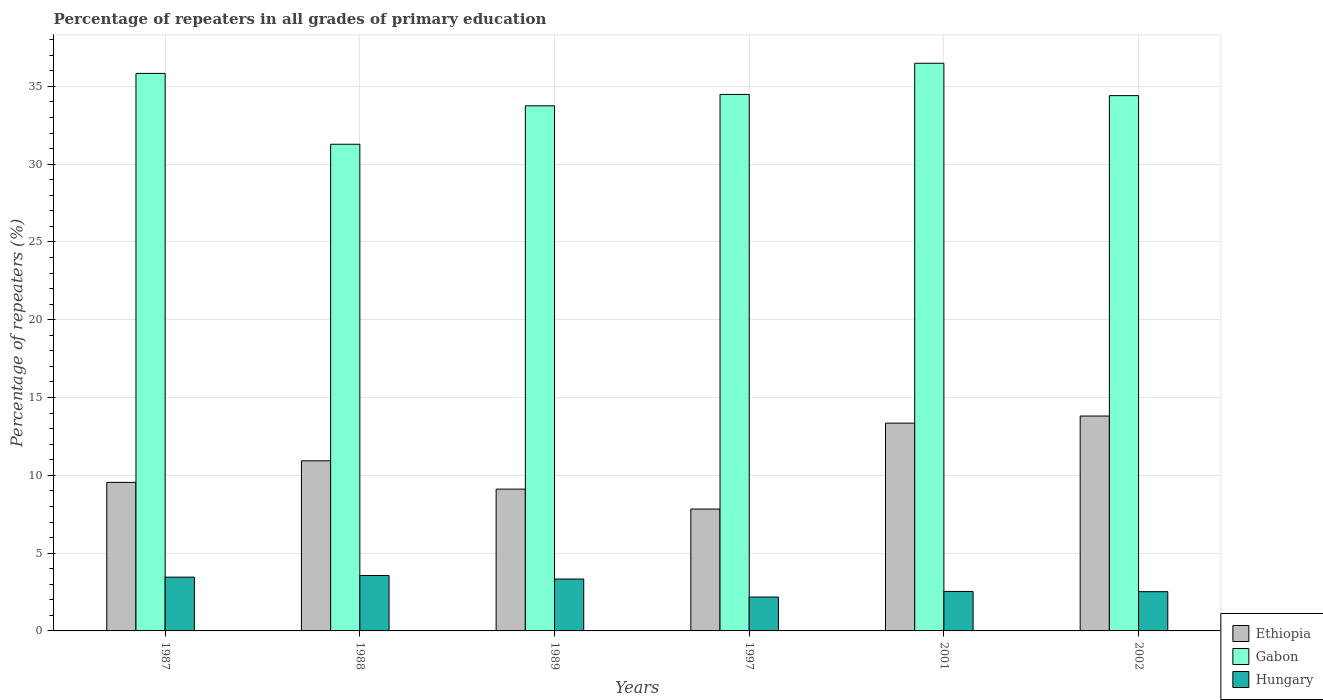How many different coloured bars are there?
Your response must be concise. 3. Are the number of bars per tick equal to the number of legend labels?
Keep it short and to the point. Yes. How many bars are there on the 4th tick from the left?
Keep it short and to the point. 3. How many bars are there on the 4th tick from the right?
Offer a terse response. 3. What is the percentage of repeaters in Hungary in 2001?
Your answer should be compact. 2.54. Across all years, what is the maximum percentage of repeaters in Hungary?
Your answer should be compact. 3.56. Across all years, what is the minimum percentage of repeaters in Gabon?
Your answer should be compact. 31.28. In which year was the percentage of repeaters in Hungary maximum?
Offer a terse response. 1988. In which year was the percentage of repeaters in Ethiopia minimum?
Your answer should be compact. 1997. What is the total percentage of repeaters in Gabon in the graph?
Your response must be concise. 206.24. What is the difference between the percentage of repeaters in Hungary in 1988 and that in 2001?
Offer a very short reply. 1.03. What is the difference between the percentage of repeaters in Ethiopia in 1997 and the percentage of repeaters in Hungary in 2002?
Keep it short and to the point. 5.31. What is the average percentage of repeaters in Hungary per year?
Your response must be concise. 2.93. In the year 1989, what is the difference between the percentage of repeaters in Gabon and percentage of repeaters in Ethiopia?
Ensure brevity in your answer.  24.64. What is the ratio of the percentage of repeaters in Hungary in 1997 to that in 2001?
Your answer should be compact. 0.86. Is the percentage of repeaters in Gabon in 1987 less than that in 1989?
Make the answer very short. No. Is the difference between the percentage of repeaters in Gabon in 1987 and 2002 greater than the difference between the percentage of repeaters in Ethiopia in 1987 and 2002?
Provide a short and direct response. Yes. What is the difference between the highest and the second highest percentage of repeaters in Gabon?
Offer a terse response. 0.65. What is the difference between the highest and the lowest percentage of repeaters in Hungary?
Ensure brevity in your answer.  1.39. What does the 1st bar from the left in 2002 represents?
Give a very brief answer. Ethiopia. What does the 2nd bar from the right in 1997 represents?
Provide a short and direct response. Gabon. Is it the case that in every year, the sum of the percentage of repeaters in Hungary and percentage of repeaters in Gabon is greater than the percentage of repeaters in Ethiopia?
Give a very brief answer. Yes. How many bars are there?
Give a very brief answer. 18. Are all the bars in the graph horizontal?
Ensure brevity in your answer.  No. How many years are there in the graph?
Offer a very short reply. 6. What is the difference between two consecutive major ticks on the Y-axis?
Keep it short and to the point. 5. Are the values on the major ticks of Y-axis written in scientific E-notation?
Make the answer very short. No. Does the graph contain any zero values?
Make the answer very short. No. Does the graph contain grids?
Give a very brief answer. Yes. Where does the legend appear in the graph?
Keep it short and to the point. Bottom right. How many legend labels are there?
Make the answer very short. 3. How are the legend labels stacked?
Your answer should be very brief. Vertical. What is the title of the graph?
Provide a succinct answer. Percentage of repeaters in all grades of primary education. Does "Low income" appear as one of the legend labels in the graph?
Give a very brief answer. No. What is the label or title of the X-axis?
Your answer should be compact. Years. What is the label or title of the Y-axis?
Keep it short and to the point. Percentage of repeaters (%). What is the Percentage of repeaters (%) of Ethiopia in 1987?
Offer a terse response. 9.55. What is the Percentage of repeaters (%) of Gabon in 1987?
Offer a terse response. 35.83. What is the Percentage of repeaters (%) of Hungary in 1987?
Your answer should be compact. 3.46. What is the Percentage of repeaters (%) in Ethiopia in 1988?
Your response must be concise. 10.93. What is the Percentage of repeaters (%) in Gabon in 1988?
Give a very brief answer. 31.28. What is the Percentage of repeaters (%) in Hungary in 1988?
Your answer should be very brief. 3.56. What is the Percentage of repeaters (%) in Ethiopia in 1989?
Your answer should be compact. 9.11. What is the Percentage of repeaters (%) of Gabon in 1989?
Make the answer very short. 33.75. What is the Percentage of repeaters (%) in Hungary in 1989?
Offer a terse response. 3.33. What is the Percentage of repeaters (%) in Ethiopia in 1997?
Provide a succinct answer. 7.83. What is the Percentage of repeaters (%) of Gabon in 1997?
Provide a short and direct response. 34.48. What is the Percentage of repeaters (%) of Hungary in 1997?
Your response must be concise. 2.18. What is the Percentage of repeaters (%) in Ethiopia in 2001?
Your response must be concise. 13.36. What is the Percentage of repeaters (%) of Gabon in 2001?
Offer a very short reply. 36.49. What is the Percentage of repeaters (%) of Hungary in 2001?
Make the answer very short. 2.54. What is the Percentage of repeaters (%) of Ethiopia in 2002?
Make the answer very short. 13.81. What is the Percentage of repeaters (%) of Gabon in 2002?
Your response must be concise. 34.41. What is the Percentage of repeaters (%) in Hungary in 2002?
Your response must be concise. 2.52. Across all years, what is the maximum Percentage of repeaters (%) of Ethiopia?
Provide a short and direct response. 13.81. Across all years, what is the maximum Percentage of repeaters (%) in Gabon?
Ensure brevity in your answer.  36.49. Across all years, what is the maximum Percentage of repeaters (%) in Hungary?
Keep it short and to the point. 3.56. Across all years, what is the minimum Percentage of repeaters (%) in Ethiopia?
Offer a very short reply. 7.83. Across all years, what is the minimum Percentage of repeaters (%) of Gabon?
Your answer should be very brief. 31.28. Across all years, what is the minimum Percentage of repeaters (%) in Hungary?
Provide a short and direct response. 2.18. What is the total Percentage of repeaters (%) of Ethiopia in the graph?
Your answer should be very brief. 64.6. What is the total Percentage of repeaters (%) of Gabon in the graph?
Give a very brief answer. 206.24. What is the total Percentage of repeaters (%) of Hungary in the graph?
Make the answer very short. 17.59. What is the difference between the Percentage of repeaters (%) in Ethiopia in 1987 and that in 1988?
Provide a short and direct response. -1.39. What is the difference between the Percentage of repeaters (%) in Gabon in 1987 and that in 1988?
Offer a very short reply. 4.55. What is the difference between the Percentage of repeaters (%) in Hungary in 1987 and that in 1988?
Provide a succinct answer. -0.11. What is the difference between the Percentage of repeaters (%) of Ethiopia in 1987 and that in 1989?
Your answer should be very brief. 0.43. What is the difference between the Percentage of repeaters (%) in Gabon in 1987 and that in 1989?
Your answer should be compact. 2.08. What is the difference between the Percentage of repeaters (%) of Hungary in 1987 and that in 1989?
Offer a very short reply. 0.12. What is the difference between the Percentage of repeaters (%) in Ethiopia in 1987 and that in 1997?
Offer a very short reply. 1.71. What is the difference between the Percentage of repeaters (%) in Gabon in 1987 and that in 1997?
Ensure brevity in your answer.  1.35. What is the difference between the Percentage of repeaters (%) of Hungary in 1987 and that in 1997?
Offer a terse response. 1.28. What is the difference between the Percentage of repeaters (%) in Ethiopia in 1987 and that in 2001?
Give a very brief answer. -3.81. What is the difference between the Percentage of repeaters (%) in Gabon in 1987 and that in 2001?
Give a very brief answer. -0.65. What is the difference between the Percentage of repeaters (%) in Hungary in 1987 and that in 2001?
Give a very brief answer. 0.92. What is the difference between the Percentage of repeaters (%) of Ethiopia in 1987 and that in 2002?
Provide a short and direct response. -4.27. What is the difference between the Percentage of repeaters (%) in Gabon in 1987 and that in 2002?
Your answer should be very brief. 1.43. What is the difference between the Percentage of repeaters (%) in Hungary in 1987 and that in 2002?
Your answer should be very brief. 0.93. What is the difference between the Percentage of repeaters (%) of Ethiopia in 1988 and that in 1989?
Provide a succinct answer. 1.82. What is the difference between the Percentage of repeaters (%) of Gabon in 1988 and that in 1989?
Provide a succinct answer. -2.47. What is the difference between the Percentage of repeaters (%) of Hungary in 1988 and that in 1989?
Make the answer very short. 0.23. What is the difference between the Percentage of repeaters (%) in Ethiopia in 1988 and that in 1997?
Provide a succinct answer. 3.1. What is the difference between the Percentage of repeaters (%) of Gabon in 1988 and that in 1997?
Provide a short and direct response. -3.2. What is the difference between the Percentage of repeaters (%) in Hungary in 1988 and that in 1997?
Provide a succinct answer. 1.39. What is the difference between the Percentage of repeaters (%) in Ethiopia in 1988 and that in 2001?
Make the answer very short. -2.42. What is the difference between the Percentage of repeaters (%) in Gabon in 1988 and that in 2001?
Make the answer very short. -5.21. What is the difference between the Percentage of repeaters (%) in Hungary in 1988 and that in 2001?
Your answer should be very brief. 1.03. What is the difference between the Percentage of repeaters (%) in Ethiopia in 1988 and that in 2002?
Offer a terse response. -2.88. What is the difference between the Percentage of repeaters (%) of Gabon in 1988 and that in 2002?
Your answer should be very brief. -3.12. What is the difference between the Percentage of repeaters (%) in Hungary in 1988 and that in 2002?
Provide a short and direct response. 1.04. What is the difference between the Percentage of repeaters (%) in Ethiopia in 1989 and that in 1997?
Make the answer very short. 1.28. What is the difference between the Percentage of repeaters (%) in Gabon in 1989 and that in 1997?
Make the answer very short. -0.73. What is the difference between the Percentage of repeaters (%) of Hungary in 1989 and that in 1997?
Ensure brevity in your answer.  1.16. What is the difference between the Percentage of repeaters (%) in Ethiopia in 1989 and that in 2001?
Offer a terse response. -4.24. What is the difference between the Percentage of repeaters (%) of Gabon in 1989 and that in 2001?
Offer a very short reply. -2.73. What is the difference between the Percentage of repeaters (%) of Hungary in 1989 and that in 2001?
Ensure brevity in your answer.  0.8. What is the difference between the Percentage of repeaters (%) in Ethiopia in 1989 and that in 2002?
Provide a short and direct response. -4.7. What is the difference between the Percentage of repeaters (%) of Gabon in 1989 and that in 2002?
Provide a succinct answer. -0.65. What is the difference between the Percentage of repeaters (%) of Hungary in 1989 and that in 2002?
Offer a terse response. 0.81. What is the difference between the Percentage of repeaters (%) in Ethiopia in 1997 and that in 2001?
Ensure brevity in your answer.  -5.52. What is the difference between the Percentage of repeaters (%) of Gabon in 1997 and that in 2001?
Your answer should be very brief. -2. What is the difference between the Percentage of repeaters (%) of Hungary in 1997 and that in 2001?
Give a very brief answer. -0.36. What is the difference between the Percentage of repeaters (%) in Ethiopia in 1997 and that in 2002?
Make the answer very short. -5.98. What is the difference between the Percentage of repeaters (%) in Gabon in 1997 and that in 2002?
Your answer should be compact. 0.08. What is the difference between the Percentage of repeaters (%) in Hungary in 1997 and that in 2002?
Provide a succinct answer. -0.34. What is the difference between the Percentage of repeaters (%) of Ethiopia in 2001 and that in 2002?
Make the answer very short. -0.46. What is the difference between the Percentage of repeaters (%) of Gabon in 2001 and that in 2002?
Ensure brevity in your answer.  2.08. What is the difference between the Percentage of repeaters (%) of Hungary in 2001 and that in 2002?
Make the answer very short. 0.01. What is the difference between the Percentage of repeaters (%) of Ethiopia in 1987 and the Percentage of repeaters (%) of Gabon in 1988?
Your answer should be very brief. -21.73. What is the difference between the Percentage of repeaters (%) in Ethiopia in 1987 and the Percentage of repeaters (%) in Hungary in 1988?
Your response must be concise. 5.98. What is the difference between the Percentage of repeaters (%) of Gabon in 1987 and the Percentage of repeaters (%) of Hungary in 1988?
Your response must be concise. 32.27. What is the difference between the Percentage of repeaters (%) in Ethiopia in 1987 and the Percentage of repeaters (%) in Gabon in 1989?
Make the answer very short. -24.21. What is the difference between the Percentage of repeaters (%) in Ethiopia in 1987 and the Percentage of repeaters (%) in Hungary in 1989?
Provide a short and direct response. 6.21. What is the difference between the Percentage of repeaters (%) of Gabon in 1987 and the Percentage of repeaters (%) of Hungary in 1989?
Keep it short and to the point. 32.5. What is the difference between the Percentage of repeaters (%) in Ethiopia in 1987 and the Percentage of repeaters (%) in Gabon in 1997?
Your response must be concise. -24.94. What is the difference between the Percentage of repeaters (%) in Ethiopia in 1987 and the Percentage of repeaters (%) in Hungary in 1997?
Offer a terse response. 7.37. What is the difference between the Percentage of repeaters (%) in Gabon in 1987 and the Percentage of repeaters (%) in Hungary in 1997?
Provide a short and direct response. 33.66. What is the difference between the Percentage of repeaters (%) of Ethiopia in 1987 and the Percentage of repeaters (%) of Gabon in 2001?
Keep it short and to the point. -26.94. What is the difference between the Percentage of repeaters (%) of Ethiopia in 1987 and the Percentage of repeaters (%) of Hungary in 2001?
Offer a terse response. 7.01. What is the difference between the Percentage of repeaters (%) in Gabon in 1987 and the Percentage of repeaters (%) in Hungary in 2001?
Provide a succinct answer. 33.3. What is the difference between the Percentage of repeaters (%) of Ethiopia in 1987 and the Percentage of repeaters (%) of Gabon in 2002?
Ensure brevity in your answer.  -24.86. What is the difference between the Percentage of repeaters (%) in Ethiopia in 1987 and the Percentage of repeaters (%) in Hungary in 2002?
Offer a very short reply. 7.02. What is the difference between the Percentage of repeaters (%) in Gabon in 1987 and the Percentage of repeaters (%) in Hungary in 2002?
Ensure brevity in your answer.  33.31. What is the difference between the Percentage of repeaters (%) of Ethiopia in 1988 and the Percentage of repeaters (%) of Gabon in 1989?
Ensure brevity in your answer.  -22.82. What is the difference between the Percentage of repeaters (%) in Ethiopia in 1988 and the Percentage of repeaters (%) in Hungary in 1989?
Ensure brevity in your answer.  7.6. What is the difference between the Percentage of repeaters (%) of Gabon in 1988 and the Percentage of repeaters (%) of Hungary in 1989?
Give a very brief answer. 27.95. What is the difference between the Percentage of repeaters (%) of Ethiopia in 1988 and the Percentage of repeaters (%) of Gabon in 1997?
Your answer should be compact. -23.55. What is the difference between the Percentage of repeaters (%) of Ethiopia in 1988 and the Percentage of repeaters (%) of Hungary in 1997?
Provide a succinct answer. 8.76. What is the difference between the Percentage of repeaters (%) of Gabon in 1988 and the Percentage of repeaters (%) of Hungary in 1997?
Keep it short and to the point. 29.1. What is the difference between the Percentage of repeaters (%) in Ethiopia in 1988 and the Percentage of repeaters (%) in Gabon in 2001?
Your response must be concise. -25.55. What is the difference between the Percentage of repeaters (%) of Ethiopia in 1988 and the Percentage of repeaters (%) of Hungary in 2001?
Ensure brevity in your answer.  8.4. What is the difference between the Percentage of repeaters (%) in Gabon in 1988 and the Percentage of repeaters (%) in Hungary in 2001?
Make the answer very short. 28.74. What is the difference between the Percentage of repeaters (%) of Ethiopia in 1988 and the Percentage of repeaters (%) of Gabon in 2002?
Your answer should be very brief. -23.47. What is the difference between the Percentage of repeaters (%) of Ethiopia in 1988 and the Percentage of repeaters (%) of Hungary in 2002?
Give a very brief answer. 8.41. What is the difference between the Percentage of repeaters (%) of Gabon in 1988 and the Percentage of repeaters (%) of Hungary in 2002?
Provide a succinct answer. 28.76. What is the difference between the Percentage of repeaters (%) of Ethiopia in 1989 and the Percentage of repeaters (%) of Gabon in 1997?
Make the answer very short. -25.37. What is the difference between the Percentage of repeaters (%) in Ethiopia in 1989 and the Percentage of repeaters (%) in Hungary in 1997?
Ensure brevity in your answer.  6.94. What is the difference between the Percentage of repeaters (%) in Gabon in 1989 and the Percentage of repeaters (%) in Hungary in 1997?
Keep it short and to the point. 31.57. What is the difference between the Percentage of repeaters (%) in Ethiopia in 1989 and the Percentage of repeaters (%) in Gabon in 2001?
Make the answer very short. -27.37. What is the difference between the Percentage of repeaters (%) in Ethiopia in 1989 and the Percentage of repeaters (%) in Hungary in 2001?
Offer a terse response. 6.58. What is the difference between the Percentage of repeaters (%) of Gabon in 1989 and the Percentage of repeaters (%) of Hungary in 2001?
Ensure brevity in your answer.  31.22. What is the difference between the Percentage of repeaters (%) of Ethiopia in 1989 and the Percentage of repeaters (%) of Gabon in 2002?
Provide a short and direct response. -25.29. What is the difference between the Percentage of repeaters (%) of Ethiopia in 1989 and the Percentage of repeaters (%) of Hungary in 2002?
Your response must be concise. 6.59. What is the difference between the Percentage of repeaters (%) in Gabon in 1989 and the Percentage of repeaters (%) in Hungary in 2002?
Make the answer very short. 31.23. What is the difference between the Percentage of repeaters (%) of Ethiopia in 1997 and the Percentage of repeaters (%) of Gabon in 2001?
Provide a succinct answer. -28.65. What is the difference between the Percentage of repeaters (%) in Ethiopia in 1997 and the Percentage of repeaters (%) in Hungary in 2001?
Your answer should be very brief. 5.3. What is the difference between the Percentage of repeaters (%) in Gabon in 1997 and the Percentage of repeaters (%) in Hungary in 2001?
Your answer should be compact. 31.95. What is the difference between the Percentage of repeaters (%) of Ethiopia in 1997 and the Percentage of repeaters (%) of Gabon in 2002?
Provide a succinct answer. -26.57. What is the difference between the Percentage of repeaters (%) in Ethiopia in 1997 and the Percentage of repeaters (%) in Hungary in 2002?
Provide a succinct answer. 5.31. What is the difference between the Percentage of repeaters (%) of Gabon in 1997 and the Percentage of repeaters (%) of Hungary in 2002?
Provide a succinct answer. 31.96. What is the difference between the Percentage of repeaters (%) in Ethiopia in 2001 and the Percentage of repeaters (%) in Gabon in 2002?
Ensure brevity in your answer.  -21.05. What is the difference between the Percentage of repeaters (%) in Ethiopia in 2001 and the Percentage of repeaters (%) in Hungary in 2002?
Ensure brevity in your answer.  10.83. What is the difference between the Percentage of repeaters (%) in Gabon in 2001 and the Percentage of repeaters (%) in Hungary in 2002?
Give a very brief answer. 33.96. What is the average Percentage of repeaters (%) in Ethiopia per year?
Offer a terse response. 10.77. What is the average Percentage of repeaters (%) in Gabon per year?
Provide a short and direct response. 34.37. What is the average Percentage of repeaters (%) in Hungary per year?
Ensure brevity in your answer.  2.93. In the year 1987, what is the difference between the Percentage of repeaters (%) in Ethiopia and Percentage of repeaters (%) in Gabon?
Ensure brevity in your answer.  -26.29. In the year 1987, what is the difference between the Percentage of repeaters (%) in Ethiopia and Percentage of repeaters (%) in Hungary?
Provide a succinct answer. 6.09. In the year 1987, what is the difference between the Percentage of repeaters (%) in Gabon and Percentage of repeaters (%) in Hungary?
Provide a succinct answer. 32.38. In the year 1988, what is the difference between the Percentage of repeaters (%) in Ethiopia and Percentage of repeaters (%) in Gabon?
Your answer should be very brief. -20.35. In the year 1988, what is the difference between the Percentage of repeaters (%) of Ethiopia and Percentage of repeaters (%) of Hungary?
Offer a very short reply. 7.37. In the year 1988, what is the difference between the Percentage of repeaters (%) in Gabon and Percentage of repeaters (%) in Hungary?
Your response must be concise. 27.72. In the year 1989, what is the difference between the Percentage of repeaters (%) in Ethiopia and Percentage of repeaters (%) in Gabon?
Your response must be concise. -24.64. In the year 1989, what is the difference between the Percentage of repeaters (%) of Ethiopia and Percentage of repeaters (%) of Hungary?
Make the answer very short. 5.78. In the year 1989, what is the difference between the Percentage of repeaters (%) of Gabon and Percentage of repeaters (%) of Hungary?
Offer a very short reply. 30.42. In the year 1997, what is the difference between the Percentage of repeaters (%) in Ethiopia and Percentage of repeaters (%) in Gabon?
Your response must be concise. -26.65. In the year 1997, what is the difference between the Percentage of repeaters (%) of Ethiopia and Percentage of repeaters (%) of Hungary?
Your response must be concise. 5.65. In the year 1997, what is the difference between the Percentage of repeaters (%) of Gabon and Percentage of repeaters (%) of Hungary?
Offer a very short reply. 32.31. In the year 2001, what is the difference between the Percentage of repeaters (%) in Ethiopia and Percentage of repeaters (%) in Gabon?
Make the answer very short. -23.13. In the year 2001, what is the difference between the Percentage of repeaters (%) in Ethiopia and Percentage of repeaters (%) in Hungary?
Offer a very short reply. 10.82. In the year 2001, what is the difference between the Percentage of repeaters (%) in Gabon and Percentage of repeaters (%) in Hungary?
Ensure brevity in your answer.  33.95. In the year 2002, what is the difference between the Percentage of repeaters (%) in Ethiopia and Percentage of repeaters (%) in Gabon?
Provide a short and direct response. -20.59. In the year 2002, what is the difference between the Percentage of repeaters (%) in Ethiopia and Percentage of repeaters (%) in Hungary?
Offer a very short reply. 11.29. In the year 2002, what is the difference between the Percentage of repeaters (%) of Gabon and Percentage of repeaters (%) of Hungary?
Make the answer very short. 31.88. What is the ratio of the Percentage of repeaters (%) of Ethiopia in 1987 to that in 1988?
Your answer should be very brief. 0.87. What is the ratio of the Percentage of repeaters (%) of Gabon in 1987 to that in 1988?
Offer a very short reply. 1.15. What is the ratio of the Percentage of repeaters (%) in Hungary in 1987 to that in 1988?
Offer a terse response. 0.97. What is the ratio of the Percentage of repeaters (%) in Ethiopia in 1987 to that in 1989?
Provide a short and direct response. 1.05. What is the ratio of the Percentage of repeaters (%) of Gabon in 1987 to that in 1989?
Ensure brevity in your answer.  1.06. What is the ratio of the Percentage of repeaters (%) in Hungary in 1987 to that in 1989?
Provide a short and direct response. 1.04. What is the ratio of the Percentage of repeaters (%) in Ethiopia in 1987 to that in 1997?
Your response must be concise. 1.22. What is the ratio of the Percentage of repeaters (%) in Gabon in 1987 to that in 1997?
Your answer should be very brief. 1.04. What is the ratio of the Percentage of repeaters (%) in Hungary in 1987 to that in 1997?
Provide a short and direct response. 1.59. What is the ratio of the Percentage of repeaters (%) of Ethiopia in 1987 to that in 2001?
Provide a succinct answer. 0.71. What is the ratio of the Percentage of repeaters (%) in Gabon in 1987 to that in 2001?
Give a very brief answer. 0.98. What is the ratio of the Percentage of repeaters (%) in Hungary in 1987 to that in 2001?
Keep it short and to the point. 1.36. What is the ratio of the Percentage of repeaters (%) of Ethiopia in 1987 to that in 2002?
Offer a terse response. 0.69. What is the ratio of the Percentage of repeaters (%) in Gabon in 1987 to that in 2002?
Give a very brief answer. 1.04. What is the ratio of the Percentage of repeaters (%) in Hungary in 1987 to that in 2002?
Give a very brief answer. 1.37. What is the ratio of the Percentage of repeaters (%) of Ethiopia in 1988 to that in 1989?
Make the answer very short. 1.2. What is the ratio of the Percentage of repeaters (%) in Gabon in 1988 to that in 1989?
Provide a succinct answer. 0.93. What is the ratio of the Percentage of repeaters (%) of Hungary in 1988 to that in 1989?
Give a very brief answer. 1.07. What is the ratio of the Percentage of repeaters (%) of Ethiopia in 1988 to that in 1997?
Make the answer very short. 1.4. What is the ratio of the Percentage of repeaters (%) of Gabon in 1988 to that in 1997?
Offer a very short reply. 0.91. What is the ratio of the Percentage of repeaters (%) of Hungary in 1988 to that in 1997?
Keep it short and to the point. 1.64. What is the ratio of the Percentage of repeaters (%) in Ethiopia in 1988 to that in 2001?
Your answer should be compact. 0.82. What is the ratio of the Percentage of repeaters (%) in Gabon in 1988 to that in 2001?
Provide a succinct answer. 0.86. What is the ratio of the Percentage of repeaters (%) in Hungary in 1988 to that in 2001?
Make the answer very short. 1.4. What is the ratio of the Percentage of repeaters (%) in Ethiopia in 1988 to that in 2002?
Provide a succinct answer. 0.79. What is the ratio of the Percentage of repeaters (%) of Gabon in 1988 to that in 2002?
Provide a short and direct response. 0.91. What is the ratio of the Percentage of repeaters (%) of Hungary in 1988 to that in 2002?
Make the answer very short. 1.41. What is the ratio of the Percentage of repeaters (%) of Ethiopia in 1989 to that in 1997?
Provide a short and direct response. 1.16. What is the ratio of the Percentage of repeaters (%) of Gabon in 1989 to that in 1997?
Keep it short and to the point. 0.98. What is the ratio of the Percentage of repeaters (%) of Hungary in 1989 to that in 1997?
Provide a succinct answer. 1.53. What is the ratio of the Percentage of repeaters (%) in Ethiopia in 1989 to that in 2001?
Provide a short and direct response. 0.68. What is the ratio of the Percentage of repeaters (%) in Gabon in 1989 to that in 2001?
Ensure brevity in your answer.  0.93. What is the ratio of the Percentage of repeaters (%) in Hungary in 1989 to that in 2001?
Provide a short and direct response. 1.31. What is the ratio of the Percentage of repeaters (%) in Ethiopia in 1989 to that in 2002?
Offer a very short reply. 0.66. What is the ratio of the Percentage of repeaters (%) in Gabon in 1989 to that in 2002?
Ensure brevity in your answer.  0.98. What is the ratio of the Percentage of repeaters (%) in Hungary in 1989 to that in 2002?
Provide a short and direct response. 1.32. What is the ratio of the Percentage of repeaters (%) in Ethiopia in 1997 to that in 2001?
Your answer should be very brief. 0.59. What is the ratio of the Percentage of repeaters (%) of Gabon in 1997 to that in 2001?
Offer a very short reply. 0.95. What is the ratio of the Percentage of repeaters (%) of Hungary in 1997 to that in 2001?
Your answer should be very brief. 0.86. What is the ratio of the Percentage of repeaters (%) in Ethiopia in 1997 to that in 2002?
Keep it short and to the point. 0.57. What is the ratio of the Percentage of repeaters (%) of Hungary in 1997 to that in 2002?
Provide a short and direct response. 0.86. What is the ratio of the Percentage of repeaters (%) in Ethiopia in 2001 to that in 2002?
Provide a succinct answer. 0.97. What is the ratio of the Percentage of repeaters (%) of Gabon in 2001 to that in 2002?
Offer a very short reply. 1.06. What is the ratio of the Percentage of repeaters (%) of Hungary in 2001 to that in 2002?
Ensure brevity in your answer.  1.01. What is the difference between the highest and the second highest Percentage of repeaters (%) in Ethiopia?
Keep it short and to the point. 0.46. What is the difference between the highest and the second highest Percentage of repeaters (%) in Gabon?
Your answer should be compact. 0.65. What is the difference between the highest and the second highest Percentage of repeaters (%) in Hungary?
Ensure brevity in your answer.  0.11. What is the difference between the highest and the lowest Percentage of repeaters (%) of Ethiopia?
Offer a terse response. 5.98. What is the difference between the highest and the lowest Percentage of repeaters (%) in Gabon?
Give a very brief answer. 5.21. What is the difference between the highest and the lowest Percentage of repeaters (%) of Hungary?
Offer a very short reply. 1.39. 